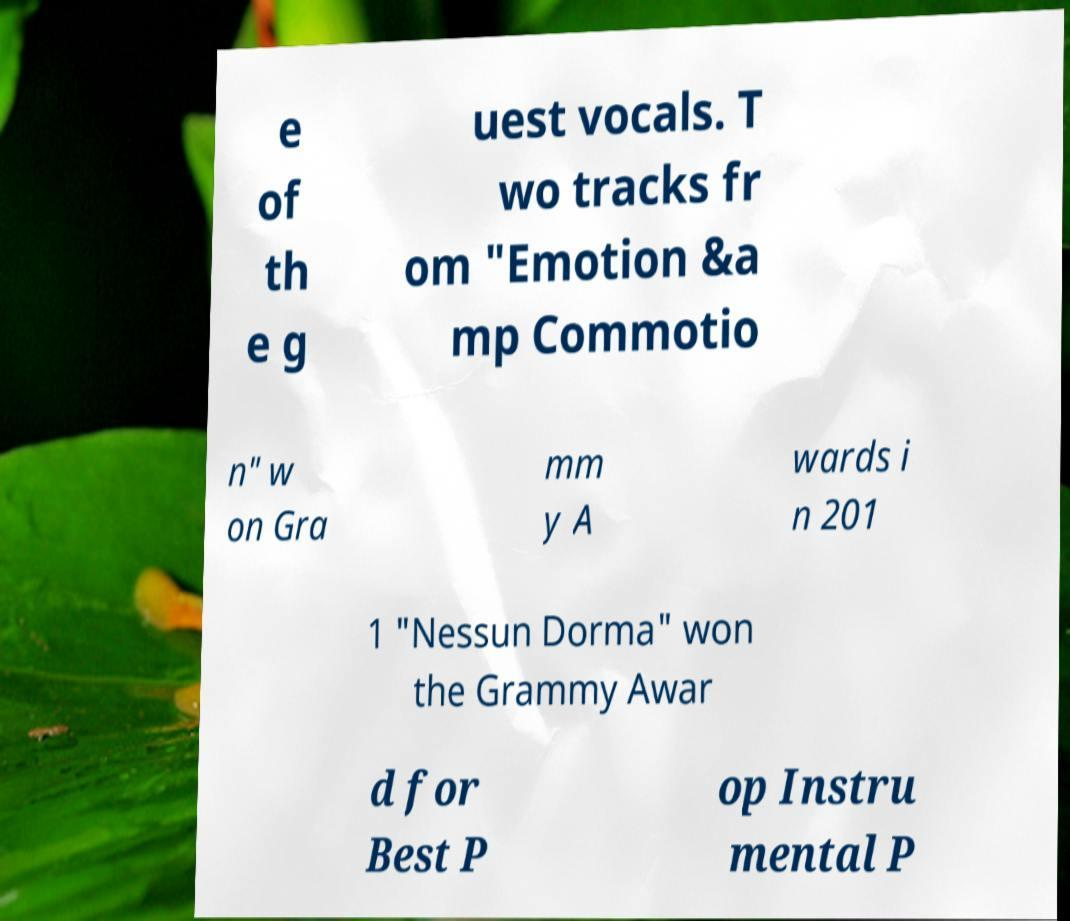For documentation purposes, I need the text within this image transcribed. Could you provide that? e of th e g uest vocals. T wo tracks fr om "Emotion &a mp Commotio n" w on Gra mm y A wards i n 201 1 "Nessun Dorma" won the Grammy Awar d for Best P op Instru mental P 